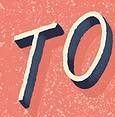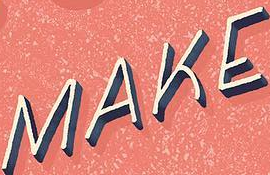What text appears in these images from left to right, separated by a semicolon? TO; MAKE 